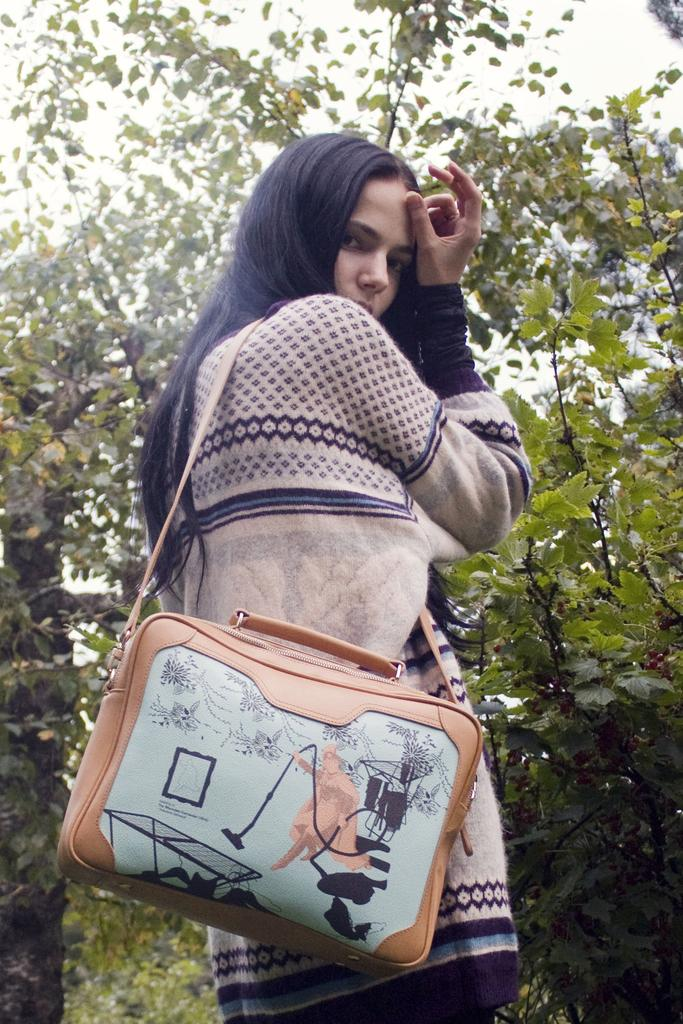Who is present in the image? There is a woman in the image. What is the woman doing in the image? The woman is standing in the image. What accessory is the woman wearing? The woman is wearing a handbag in the image. What can be seen in the background of the image? There is a tree in the background of the image. What type of prose can be heard being read by the woman in the image? There is no indication in the image that the woman is reading or speaking, so it cannot be determined what type of prose might be heard. 